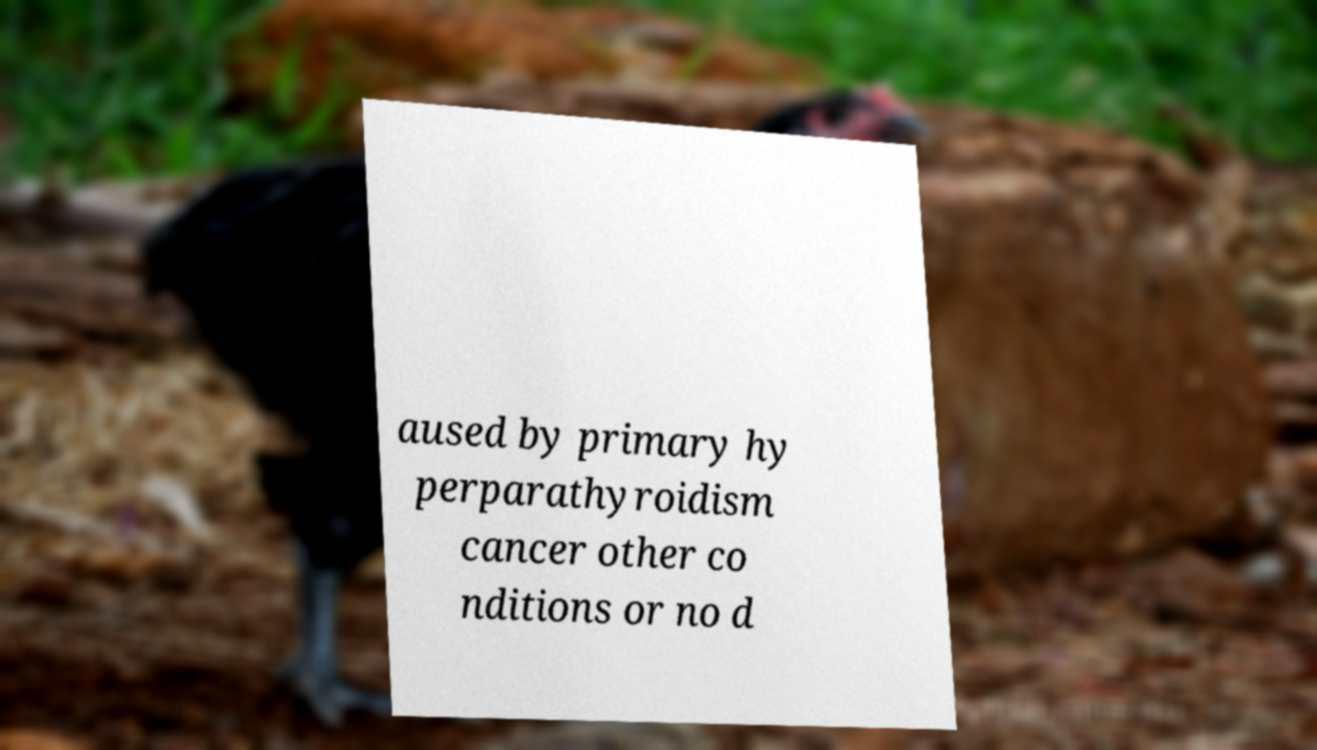What messages or text are displayed in this image? I need them in a readable, typed format. aused by primary hy perparathyroidism cancer other co nditions or no d 